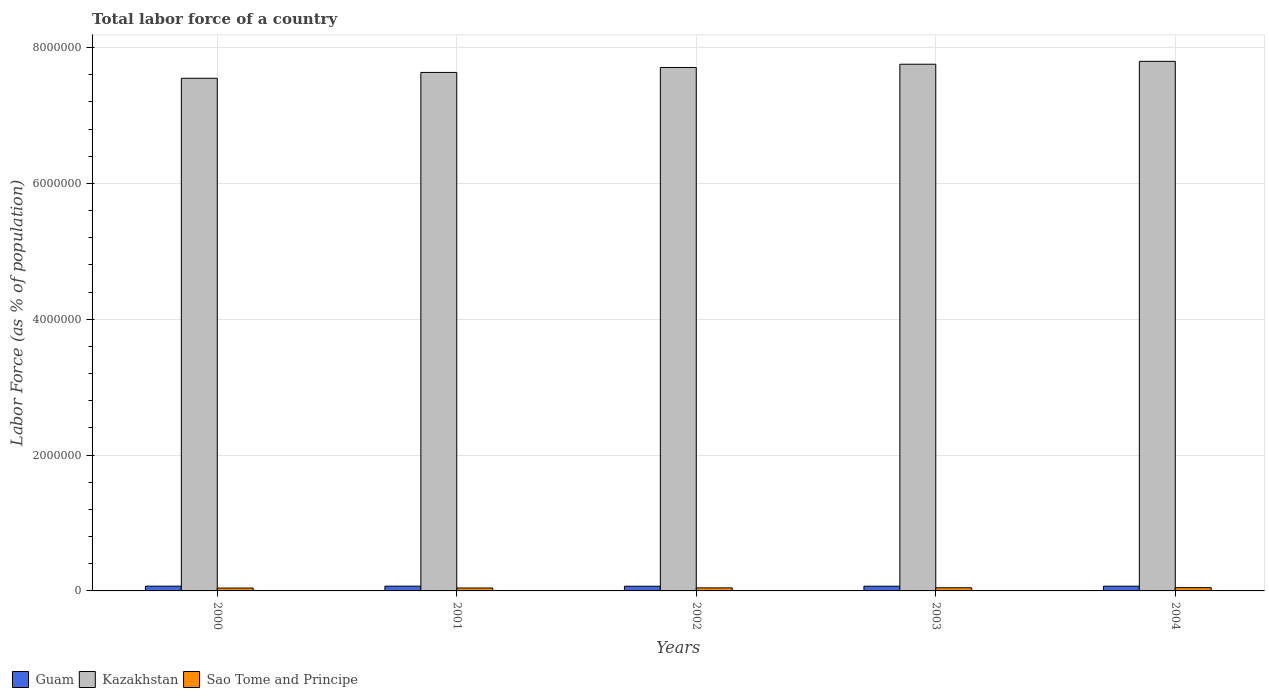How many different coloured bars are there?
Give a very brief answer. 3. How many groups of bars are there?
Provide a short and direct response. 5. Are the number of bars on each tick of the X-axis equal?
Provide a short and direct response. Yes. How many bars are there on the 4th tick from the left?
Ensure brevity in your answer.  3. What is the label of the 4th group of bars from the left?
Your answer should be compact. 2003. What is the percentage of labor force in Guam in 2000?
Make the answer very short. 7.00e+04. Across all years, what is the maximum percentage of labor force in Sao Tome and Principe?
Offer a very short reply. 4.81e+04. Across all years, what is the minimum percentage of labor force in Kazakhstan?
Provide a succinct answer. 7.55e+06. What is the total percentage of labor force in Guam in the graph?
Your answer should be very brief. 3.48e+05. What is the difference between the percentage of labor force in Kazakhstan in 2001 and that in 2002?
Your answer should be very brief. -7.29e+04. What is the difference between the percentage of labor force in Kazakhstan in 2001 and the percentage of labor force in Guam in 2004?
Provide a succinct answer. 7.57e+06. What is the average percentage of labor force in Sao Tome and Principe per year?
Ensure brevity in your answer.  4.49e+04. In the year 2002, what is the difference between the percentage of labor force in Kazakhstan and percentage of labor force in Guam?
Keep it short and to the point. 7.64e+06. What is the ratio of the percentage of labor force in Kazakhstan in 2000 to that in 2003?
Ensure brevity in your answer.  0.97. Is the percentage of labor force in Kazakhstan in 2000 less than that in 2004?
Your answer should be compact. Yes. What is the difference between the highest and the second highest percentage of labor force in Kazakhstan?
Your response must be concise. 4.24e+04. What is the difference between the highest and the lowest percentage of labor force in Guam?
Your response must be concise. 1556. In how many years, is the percentage of labor force in Kazakhstan greater than the average percentage of labor force in Kazakhstan taken over all years?
Make the answer very short. 3. What does the 1st bar from the left in 2002 represents?
Offer a very short reply. Guam. What does the 1st bar from the right in 2003 represents?
Offer a very short reply. Sao Tome and Principe. How many years are there in the graph?
Keep it short and to the point. 5. Are the values on the major ticks of Y-axis written in scientific E-notation?
Offer a terse response. No. Does the graph contain grids?
Ensure brevity in your answer.  Yes. Where does the legend appear in the graph?
Provide a succinct answer. Bottom left. What is the title of the graph?
Provide a succinct answer. Total labor force of a country. Does "Micronesia" appear as one of the legend labels in the graph?
Provide a short and direct response. No. What is the label or title of the X-axis?
Provide a succinct answer. Years. What is the label or title of the Y-axis?
Provide a succinct answer. Labor Force (as % of population). What is the Labor Force (as % of population) of Guam in 2000?
Offer a terse response. 7.00e+04. What is the Labor Force (as % of population) of Kazakhstan in 2000?
Ensure brevity in your answer.  7.55e+06. What is the Labor Force (as % of population) in Sao Tome and Principe in 2000?
Provide a short and direct response. 4.21e+04. What is the Labor Force (as % of population) in Guam in 2001?
Your response must be concise. 7.04e+04. What is the Labor Force (as % of population) of Kazakhstan in 2001?
Ensure brevity in your answer.  7.64e+06. What is the Labor Force (as % of population) in Sao Tome and Principe in 2001?
Your response must be concise. 4.32e+04. What is the Labor Force (as % of population) of Guam in 2002?
Offer a terse response. 6.88e+04. What is the Labor Force (as % of population) in Kazakhstan in 2002?
Keep it short and to the point. 7.71e+06. What is the Labor Force (as % of population) of Sao Tome and Principe in 2002?
Keep it short and to the point. 4.47e+04. What is the Labor Force (as % of population) of Guam in 2003?
Provide a short and direct response. 6.92e+04. What is the Labor Force (as % of population) of Kazakhstan in 2003?
Offer a terse response. 7.76e+06. What is the Labor Force (as % of population) of Sao Tome and Principe in 2003?
Your response must be concise. 4.64e+04. What is the Labor Force (as % of population) of Guam in 2004?
Your answer should be compact. 6.96e+04. What is the Labor Force (as % of population) of Kazakhstan in 2004?
Ensure brevity in your answer.  7.80e+06. What is the Labor Force (as % of population) of Sao Tome and Principe in 2004?
Ensure brevity in your answer.  4.81e+04. Across all years, what is the maximum Labor Force (as % of population) of Guam?
Give a very brief answer. 7.04e+04. Across all years, what is the maximum Labor Force (as % of population) of Kazakhstan?
Give a very brief answer. 7.80e+06. Across all years, what is the maximum Labor Force (as % of population) of Sao Tome and Principe?
Offer a very short reply. 4.81e+04. Across all years, what is the minimum Labor Force (as % of population) of Guam?
Your response must be concise. 6.88e+04. Across all years, what is the minimum Labor Force (as % of population) of Kazakhstan?
Give a very brief answer. 7.55e+06. Across all years, what is the minimum Labor Force (as % of population) in Sao Tome and Principe?
Your answer should be very brief. 4.21e+04. What is the total Labor Force (as % of population) in Guam in the graph?
Ensure brevity in your answer.  3.48e+05. What is the total Labor Force (as % of population) in Kazakhstan in the graph?
Offer a very short reply. 3.84e+07. What is the total Labor Force (as % of population) in Sao Tome and Principe in the graph?
Offer a very short reply. 2.25e+05. What is the difference between the Labor Force (as % of population) in Guam in 2000 and that in 2001?
Make the answer very short. -404. What is the difference between the Labor Force (as % of population) of Kazakhstan in 2000 and that in 2001?
Provide a succinct answer. -8.58e+04. What is the difference between the Labor Force (as % of population) in Sao Tome and Principe in 2000 and that in 2001?
Provide a succinct answer. -1123. What is the difference between the Labor Force (as % of population) in Guam in 2000 and that in 2002?
Make the answer very short. 1152. What is the difference between the Labor Force (as % of population) of Kazakhstan in 2000 and that in 2002?
Give a very brief answer. -1.59e+05. What is the difference between the Labor Force (as % of population) in Sao Tome and Principe in 2000 and that in 2002?
Your answer should be compact. -2620. What is the difference between the Labor Force (as % of population) of Guam in 2000 and that in 2003?
Your response must be concise. 719. What is the difference between the Labor Force (as % of population) of Kazakhstan in 2000 and that in 2003?
Your answer should be compact. -2.07e+05. What is the difference between the Labor Force (as % of population) in Sao Tome and Principe in 2000 and that in 2003?
Offer a terse response. -4322. What is the difference between the Labor Force (as % of population) in Guam in 2000 and that in 2004?
Offer a terse response. 332. What is the difference between the Labor Force (as % of population) in Kazakhstan in 2000 and that in 2004?
Offer a very short reply. -2.49e+05. What is the difference between the Labor Force (as % of population) in Sao Tome and Principe in 2000 and that in 2004?
Your answer should be compact. -6023. What is the difference between the Labor Force (as % of population) of Guam in 2001 and that in 2002?
Provide a succinct answer. 1556. What is the difference between the Labor Force (as % of population) of Kazakhstan in 2001 and that in 2002?
Keep it short and to the point. -7.29e+04. What is the difference between the Labor Force (as % of population) in Sao Tome and Principe in 2001 and that in 2002?
Give a very brief answer. -1497. What is the difference between the Labor Force (as % of population) of Guam in 2001 and that in 2003?
Your response must be concise. 1123. What is the difference between the Labor Force (as % of population) of Kazakhstan in 2001 and that in 2003?
Offer a very short reply. -1.21e+05. What is the difference between the Labor Force (as % of population) of Sao Tome and Principe in 2001 and that in 2003?
Ensure brevity in your answer.  -3199. What is the difference between the Labor Force (as % of population) in Guam in 2001 and that in 2004?
Your response must be concise. 736. What is the difference between the Labor Force (as % of population) in Kazakhstan in 2001 and that in 2004?
Offer a very short reply. -1.63e+05. What is the difference between the Labor Force (as % of population) in Sao Tome and Principe in 2001 and that in 2004?
Your response must be concise. -4900. What is the difference between the Labor Force (as % of population) in Guam in 2002 and that in 2003?
Provide a succinct answer. -433. What is the difference between the Labor Force (as % of population) in Kazakhstan in 2002 and that in 2003?
Keep it short and to the point. -4.78e+04. What is the difference between the Labor Force (as % of population) in Sao Tome and Principe in 2002 and that in 2003?
Keep it short and to the point. -1702. What is the difference between the Labor Force (as % of population) of Guam in 2002 and that in 2004?
Your response must be concise. -820. What is the difference between the Labor Force (as % of population) of Kazakhstan in 2002 and that in 2004?
Offer a terse response. -9.02e+04. What is the difference between the Labor Force (as % of population) in Sao Tome and Principe in 2002 and that in 2004?
Offer a very short reply. -3403. What is the difference between the Labor Force (as % of population) in Guam in 2003 and that in 2004?
Your response must be concise. -387. What is the difference between the Labor Force (as % of population) of Kazakhstan in 2003 and that in 2004?
Your answer should be compact. -4.24e+04. What is the difference between the Labor Force (as % of population) of Sao Tome and Principe in 2003 and that in 2004?
Your response must be concise. -1701. What is the difference between the Labor Force (as % of population) of Guam in 2000 and the Labor Force (as % of population) of Kazakhstan in 2001?
Your response must be concise. -7.57e+06. What is the difference between the Labor Force (as % of population) of Guam in 2000 and the Labor Force (as % of population) of Sao Tome and Principe in 2001?
Your response must be concise. 2.68e+04. What is the difference between the Labor Force (as % of population) in Kazakhstan in 2000 and the Labor Force (as % of population) in Sao Tome and Principe in 2001?
Provide a short and direct response. 7.51e+06. What is the difference between the Labor Force (as % of population) of Guam in 2000 and the Labor Force (as % of population) of Kazakhstan in 2002?
Your response must be concise. -7.64e+06. What is the difference between the Labor Force (as % of population) of Guam in 2000 and the Labor Force (as % of population) of Sao Tome and Principe in 2002?
Keep it short and to the point. 2.53e+04. What is the difference between the Labor Force (as % of population) in Kazakhstan in 2000 and the Labor Force (as % of population) in Sao Tome and Principe in 2002?
Offer a terse response. 7.50e+06. What is the difference between the Labor Force (as % of population) in Guam in 2000 and the Labor Force (as % of population) in Kazakhstan in 2003?
Offer a terse response. -7.69e+06. What is the difference between the Labor Force (as % of population) in Guam in 2000 and the Labor Force (as % of population) in Sao Tome and Principe in 2003?
Provide a short and direct response. 2.36e+04. What is the difference between the Labor Force (as % of population) in Kazakhstan in 2000 and the Labor Force (as % of population) in Sao Tome and Principe in 2003?
Keep it short and to the point. 7.50e+06. What is the difference between the Labor Force (as % of population) in Guam in 2000 and the Labor Force (as % of population) in Kazakhstan in 2004?
Make the answer very short. -7.73e+06. What is the difference between the Labor Force (as % of population) of Guam in 2000 and the Labor Force (as % of population) of Sao Tome and Principe in 2004?
Make the answer very short. 2.19e+04. What is the difference between the Labor Force (as % of population) of Kazakhstan in 2000 and the Labor Force (as % of population) of Sao Tome and Principe in 2004?
Keep it short and to the point. 7.50e+06. What is the difference between the Labor Force (as % of population) in Guam in 2001 and the Labor Force (as % of population) in Kazakhstan in 2002?
Provide a succinct answer. -7.64e+06. What is the difference between the Labor Force (as % of population) of Guam in 2001 and the Labor Force (as % of population) of Sao Tome and Principe in 2002?
Provide a succinct answer. 2.57e+04. What is the difference between the Labor Force (as % of population) of Kazakhstan in 2001 and the Labor Force (as % of population) of Sao Tome and Principe in 2002?
Offer a terse response. 7.59e+06. What is the difference between the Labor Force (as % of population) in Guam in 2001 and the Labor Force (as % of population) in Kazakhstan in 2003?
Give a very brief answer. -7.69e+06. What is the difference between the Labor Force (as % of population) in Guam in 2001 and the Labor Force (as % of population) in Sao Tome and Principe in 2003?
Offer a very short reply. 2.40e+04. What is the difference between the Labor Force (as % of population) of Kazakhstan in 2001 and the Labor Force (as % of population) of Sao Tome and Principe in 2003?
Give a very brief answer. 7.59e+06. What is the difference between the Labor Force (as % of population) of Guam in 2001 and the Labor Force (as % of population) of Kazakhstan in 2004?
Your answer should be very brief. -7.73e+06. What is the difference between the Labor Force (as % of population) of Guam in 2001 and the Labor Force (as % of population) of Sao Tome and Principe in 2004?
Ensure brevity in your answer.  2.23e+04. What is the difference between the Labor Force (as % of population) of Kazakhstan in 2001 and the Labor Force (as % of population) of Sao Tome and Principe in 2004?
Provide a succinct answer. 7.59e+06. What is the difference between the Labor Force (as % of population) in Guam in 2002 and the Labor Force (as % of population) in Kazakhstan in 2003?
Your response must be concise. -7.69e+06. What is the difference between the Labor Force (as % of population) in Guam in 2002 and the Labor Force (as % of population) in Sao Tome and Principe in 2003?
Your answer should be compact. 2.24e+04. What is the difference between the Labor Force (as % of population) in Kazakhstan in 2002 and the Labor Force (as % of population) in Sao Tome and Principe in 2003?
Your answer should be very brief. 7.66e+06. What is the difference between the Labor Force (as % of population) of Guam in 2002 and the Labor Force (as % of population) of Kazakhstan in 2004?
Your response must be concise. -7.73e+06. What is the difference between the Labor Force (as % of population) of Guam in 2002 and the Labor Force (as % of population) of Sao Tome and Principe in 2004?
Make the answer very short. 2.07e+04. What is the difference between the Labor Force (as % of population) in Kazakhstan in 2002 and the Labor Force (as % of population) in Sao Tome and Principe in 2004?
Give a very brief answer. 7.66e+06. What is the difference between the Labor Force (as % of population) of Guam in 2003 and the Labor Force (as % of population) of Kazakhstan in 2004?
Make the answer very short. -7.73e+06. What is the difference between the Labor Force (as % of population) in Guam in 2003 and the Labor Force (as % of population) in Sao Tome and Principe in 2004?
Provide a succinct answer. 2.11e+04. What is the difference between the Labor Force (as % of population) of Kazakhstan in 2003 and the Labor Force (as % of population) of Sao Tome and Principe in 2004?
Provide a short and direct response. 7.71e+06. What is the average Labor Force (as % of population) of Guam per year?
Provide a short and direct response. 6.96e+04. What is the average Labor Force (as % of population) of Kazakhstan per year?
Your response must be concise. 7.69e+06. What is the average Labor Force (as % of population) of Sao Tome and Principe per year?
Your response must be concise. 4.49e+04. In the year 2000, what is the difference between the Labor Force (as % of population) in Guam and Labor Force (as % of population) in Kazakhstan?
Give a very brief answer. -7.48e+06. In the year 2000, what is the difference between the Labor Force (as % of population) in Guam and Labor Force (as % of population) in Sao Tome and Principe?
Make the answer very short. 2.79e+04. In the year 2000, what is the difference between the Labor Force (as % of population) in Kazakhstan and Labor Force (as % of population) in Sao Tome and Principe?
Your answer should be very brief. 7.51e+06. In the year 2001, what is the difference between the Labor Force (as % of population) of Guam and Labor Force (as % of population) of Kazakhstan?
Your answer should be very brief. -7.56e+06. In the year 2001, what is the difference between the Labor Force (as % of population) of Guam and Labor Force (as % of population) of Sao Tome and Principe?
Your answer should be very brief. 2.72e+04. In the year 2001, what is the difference between the Labor Force (as % of population) of Kazakhstan and Labor Force (as % of population) of Sao Tome and Principe?
Your answer should be very brief. 7.59e+06. In the year 2002, what is the difference between the Labor Force (as % of population) of Guam and Labor Force (as % of population) of Kazakhstan?
Provide a short and direct response. -7.64e+06. In the year 2002, what is the difference between the Labor Force (as % of population) of Guam and Labor Force (as % of population) of Sao Tome and Principe?
Offer a very short reply. 2.41e+04. In the year 2002, what is the difference between the Labor Force (as % of population) of Kazakhstan and Labor Force (as % of population) of Sao Tome and Principe?
Make the answer very short. 7.66e+06. In the year 2003, what is the difference between the Labor Force (as % of population) of Guam and Labor Force (as % of population) of Kazakhstan?
Keep it short and to the point. -7.69e+06. In the year 2003, what is the difference between the Labor Force (as % of population) of Guam and Labor Force (as % of population) of Sao Tome and Principe?
Provide a short and direct response. 2.28e+04. In the year 2003, what is the difference between the Labor Force (as % of population) in Kazakhstan and Labor Force (as % of population) in Sao Tome and Principe?
Offer a very short reply. 7.71e+06. In the year 2004, what is the difference between the Labor Force (as % of population) of Guam and Labor Force (as % of population) of Kazakhstan?
Make the answer very short. -7.73e+06. In the year 2004, what is the difference between the Labor Force (as % of population) of Guam and Labor Force (as % of population) of Sao Tome and Principe?
Your answer should be very brief. 2.15e+04. In the year 2004, what is the difference between the Labor Force (as % of population) in Kazakhstan and Labor Force (as % of population) in Sao Tome and Principe?
Your response must be concise. 7.75e+06. What is the ratio of the Labor Force (as % of population) of Guam in 2000 to that in 2001?
Your answer should be compact. 0.99. What is the ratio of the Labor Force (as % of population) in Guam in 2000 to that in 2002?
Provide a succinct answer. 1.02. What is the ratio of the Labor Force (as % of population) of Kazakhstan in 2000 to that in 2002?
Provide a short and direct response. 0.98. What is the ratio of the Labor Force (as % of population) in Sao Tome and Principe in 2000 to that in 2002?
Give a very brief answer. 0.94. What is the ratio of the Labor Force (as % of population) in Guam in 2000 to that in 2003?
Your response must be concise. 1.01. What is the ratio of the Labor Force (as % of population) in Kazakhstan in 2000 to that in 2003?
Provide a succinct answer. 0.97. What is the ratio of the Labor Force (as % of population) of Sao Tome and Principe in 2000 to that in 2003?
Offer a terse response. 0.91. What is the ratio of the Labor Force (as % of population) of Kazakhstan in 2000 to that in 2004?
Provide a succinct answer. 0.97. What is the ratio of the Labor Force (as % of population) in Sao Tome and Principe in 2000 to that in 2004?
Your response must be concise. 0.87. What is the ratio of the Labor Force (as % of population) in Guam in 2001 to that in 2002?
Your response must be concise. 1.02. What is the ratio of the Labor Force (as % of population) of Kazakhstan in 2001 to that in 2002?
Ensure brevity in your answer.  0.99. What is the ratio of the Labor Force (as % of population) in Sao Tome and Principe in 2001 to that in 2002?
Offer a terse response. 0.97. What is the ratio of the Labor Force (as % of population) in Guam in 2001 to that in 2003?
Your answer should be very brief. 1.02. What is the ratio of the Labor Force (as % of population) in Kazakhstan in 2001 to that in 2003?
Offer a very short reply. 0.98. What is the ratio of the Labor Force (as % of population) in Sao Tome and Principe in 2001 to that in 2003?
Offer a very short reply. 0.93. What is the ratio of the Labor Force (as % of population) in Guam in 2001 to that in 2004?
Your answer should be compact. 1.01. What is the ratio of the Labor Force (as % of population) of Kazakhstan in 2001 to that in 2004?
Offer a terse response. 0.98. What is the ratio of the Labor Force (as % of population) in Sao Tome and Principe in 2001 to that in 2004?
Your response must be concise. 0.9. What is the ratio of the Labor Force (as % of population) of Sao Tome and Principe in 2002 to that in 2003?
Offer a terse response. 0.96. What is the ratio of the Labor Force (as % of population) of Kazakhstan in 2002 to that in 2004?
Your answer should be very brief. 0.99. What is the ratio of the Labor Force (as % of population) of Sao Tome and Principe in 2002 to that in 2004?
Ensure brevity in your answer.  0.93. What is the ratio of the Labor Force (as % of population) of Guam in 2003 to that in 2004?
Provide a succinct answer. 0.99. What is the ratio of the Labor Force (as % of population) of Kazakhstan in 2003 to that in 2004?
Your answer should be compact. 0.99. What is the ratio of the Labor Force (as % of population) in Sao Tome and Principe in 2003 to that in 2004?
Offer a very short reply. 0.96. What is the difference between the highest and the second highest Labor Force (as % of population) of Guam?
Provide a succinct answer. 404. What is the difference between the highest and the second highest Labor Force (as % of population) in Kazakhstan?
Offer a very short reply. 4.24e+04. What is the difference between the highest and the second highest Labor Force (as % of population) in Sao Tome and Principe?
Provide a short and direct response. 1701. What is the difference between the highest and the lowest Labor Force (as % of population) of Guam?
Offer a very short reply. 1556. What is the difference between the highest and the lowest Labor Force (as % of population) of Kazakhstan?
Give a very brief answer. 2.49e+05. What is the difference between the highest and the lowest Labor Force (as % of population) in Sao Tome and Principe?
Offer a terse response. 6023. 